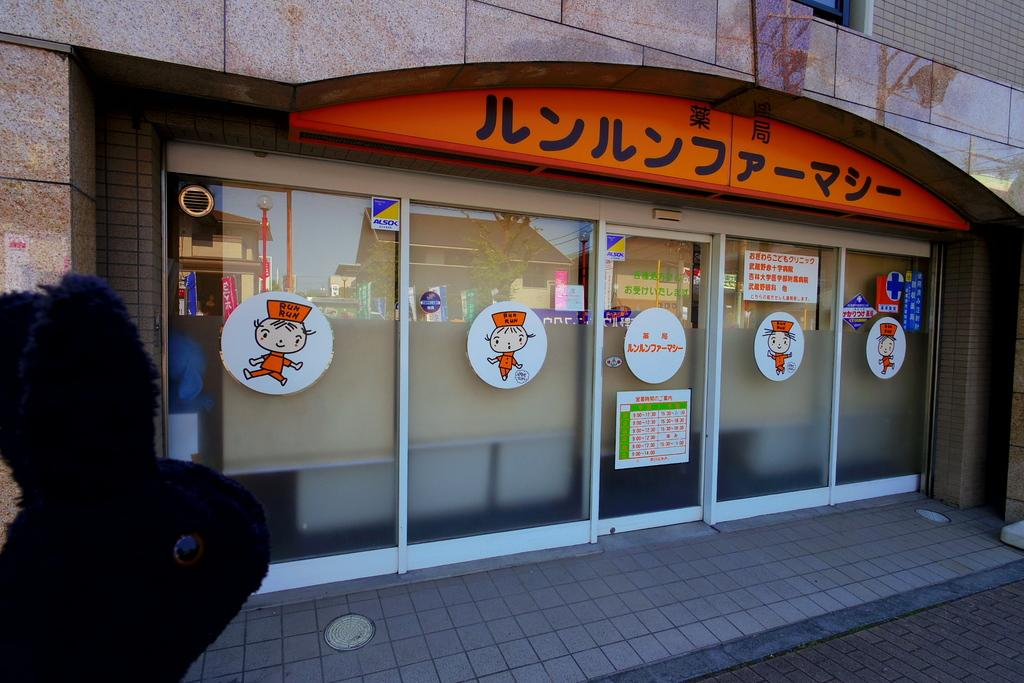What type of structure is visible in the image? There is a building in the image. Can you describe the store within the building? The store has glass walls and is visible in the image. What can be seen on the glass walls of the store? The glass walls of the store have pictures and text on them. Where is the object located in the image? The object is in the bottom left corner of the image. How much salt is present in the image? There is no salt visible in the image. Can you see a rifle in the image? There is no rifle present in the image. 